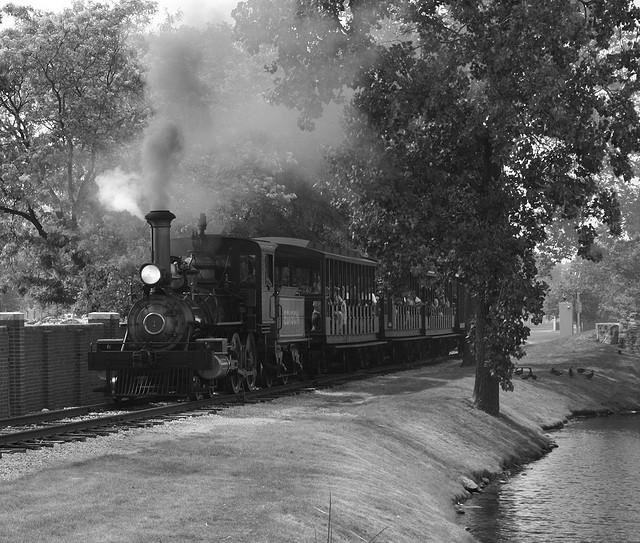What is the state of the colors here? black white 